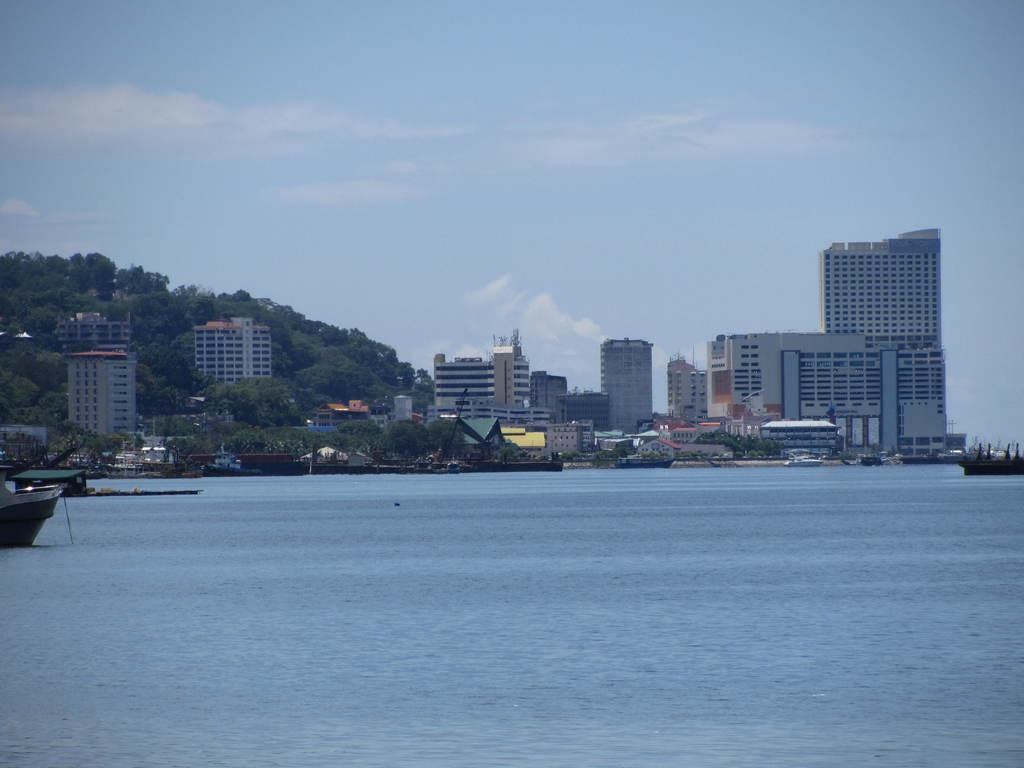What is the main subject of the image? The main subject of the image is boats. Where are the boats located? The boats are on the water. What can be seen in the background of the image? Trees, buildings, and the sky are visible in the background of the image. What is the income of the boats in the image? There is no information about the income of the boats in the image, as boats do not have income. 